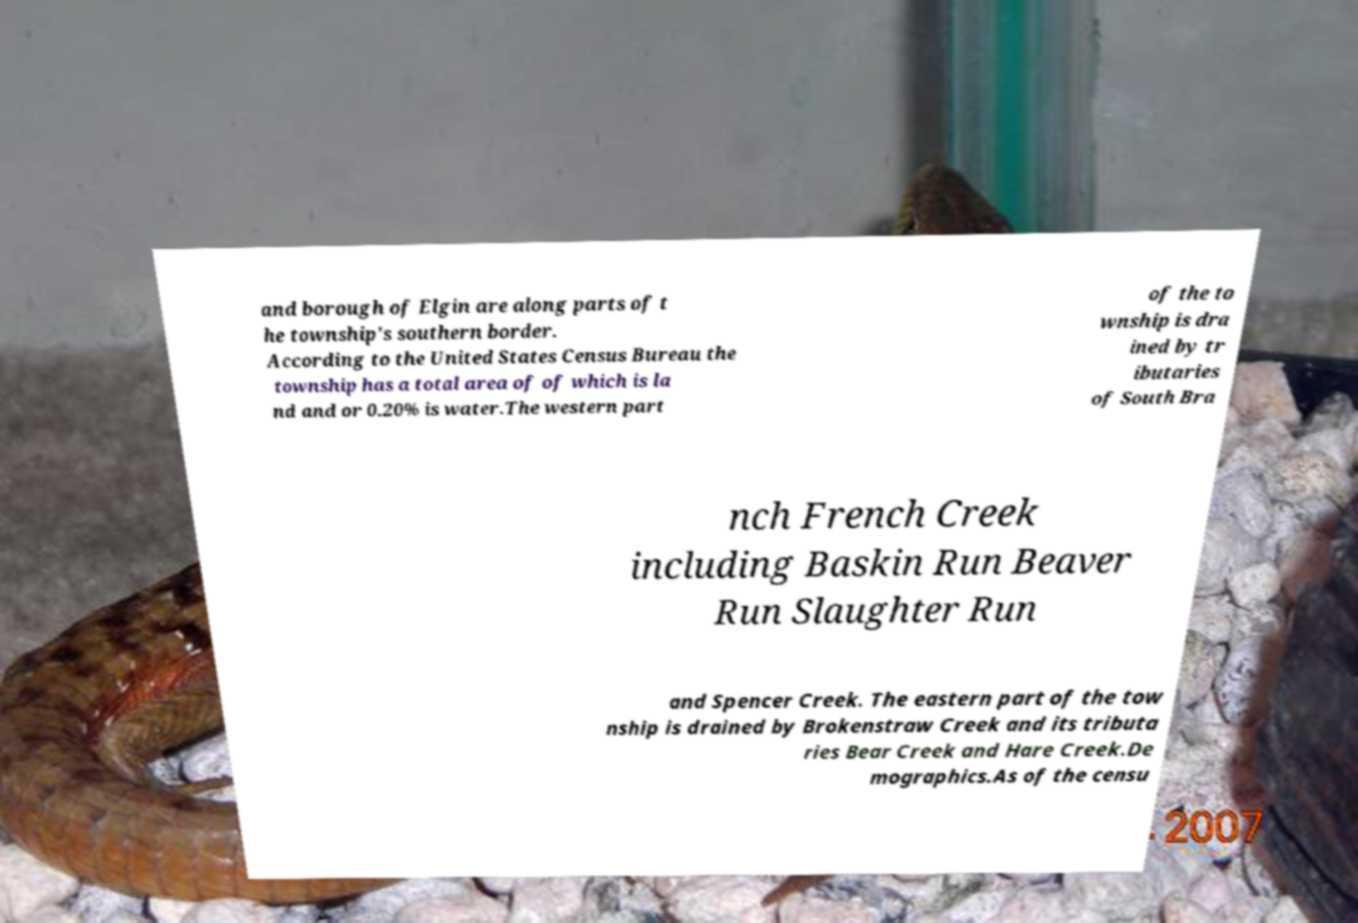What messages or text are displayed in this image? I need them in a readable, typed format. and borough of Elgin are along parts of t he township's southern border. According to the United States Census Bureau the township has a total area of of which is la nd and or 0.20% is water.The western part of the to wnship is dra ined by tr ibutaries of South Bra nch French Creek including Baskin Run Beaver Run Slaughter Run and Spencer Creek. The eastern part of the tow nship is drained by Brokenstraw Creek and its tributa ries Bear Creek and Hare Creek.De mographics.As of the censu 